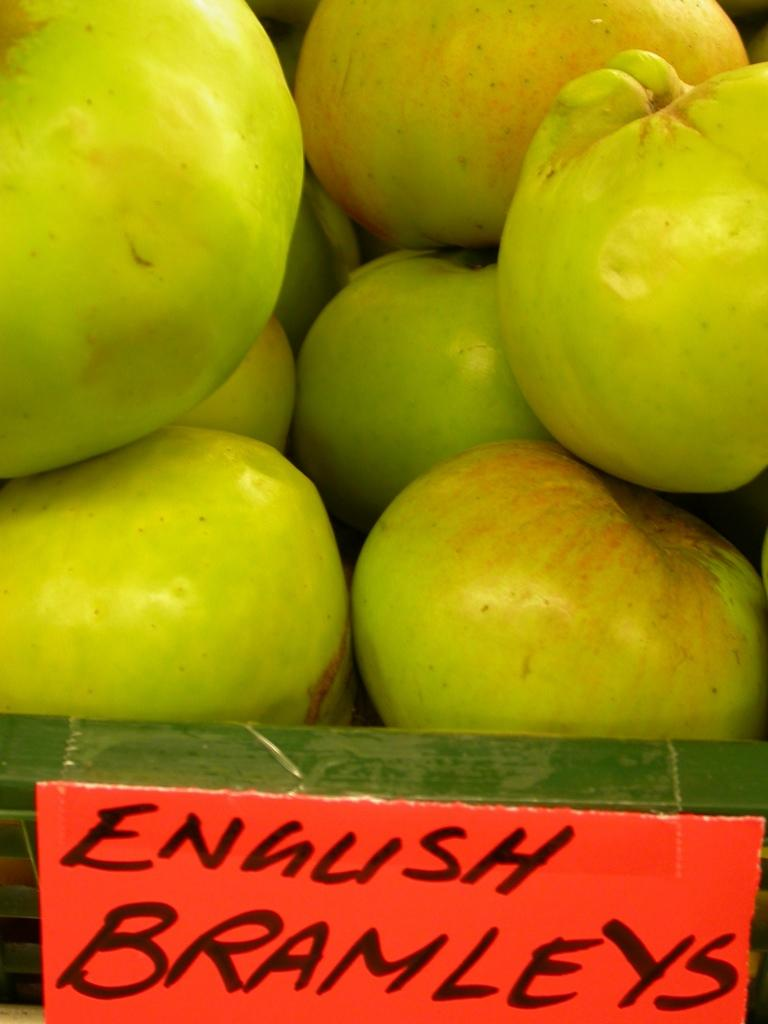What type of fruit is present in the image? There are green apples in the image. What other object can be seen at the bottom of the image? There is a board with text at the bottom of the image. What color is the sock on the apple in the image? There is no sock present in the image, and the apples are not wearing any clothing. 